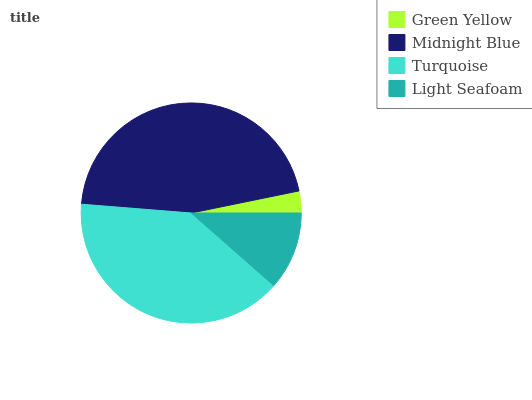Is Green Yellow the minimum?
Answer yes or no. Yes. Is Midnight Blue the maximum?
Answer yes or no. Yes. Is Turquoise the minimum?
Answer yes or no. No. Is Turquoise the maximum?
Answer yes or no. No. Is Midnight Blue greater than Turquoise?
Answer yes or no. Yes. Is Turquoise less than Midnight Blue?
Answer yes or no. Yes. Is Turquoise greater than Midnight Blue?
Answer yes or no. No. Is Midnight Blue less than Turquoise?
Answer yes or no. No. Is Turquoise the high median?
Answer yes or no. Yes. Is Light Seafoam the low median?
Answer yes or no. Yes. Is Light Seafoam the high median?
Answer yes or no. No. Is Turquoise the low median?
Answer yes or no. No. 